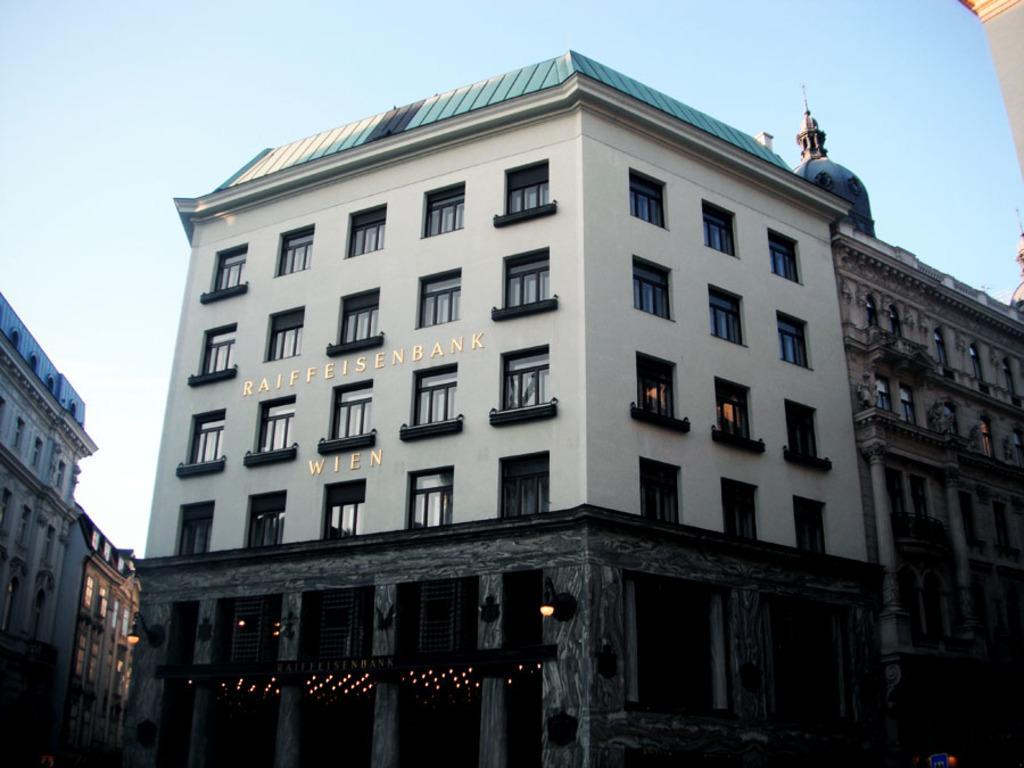In one or two sentences, can you explain what this image depicts? In the picture I can see buildings, lights and some other objects. In the background I can see the sky. 